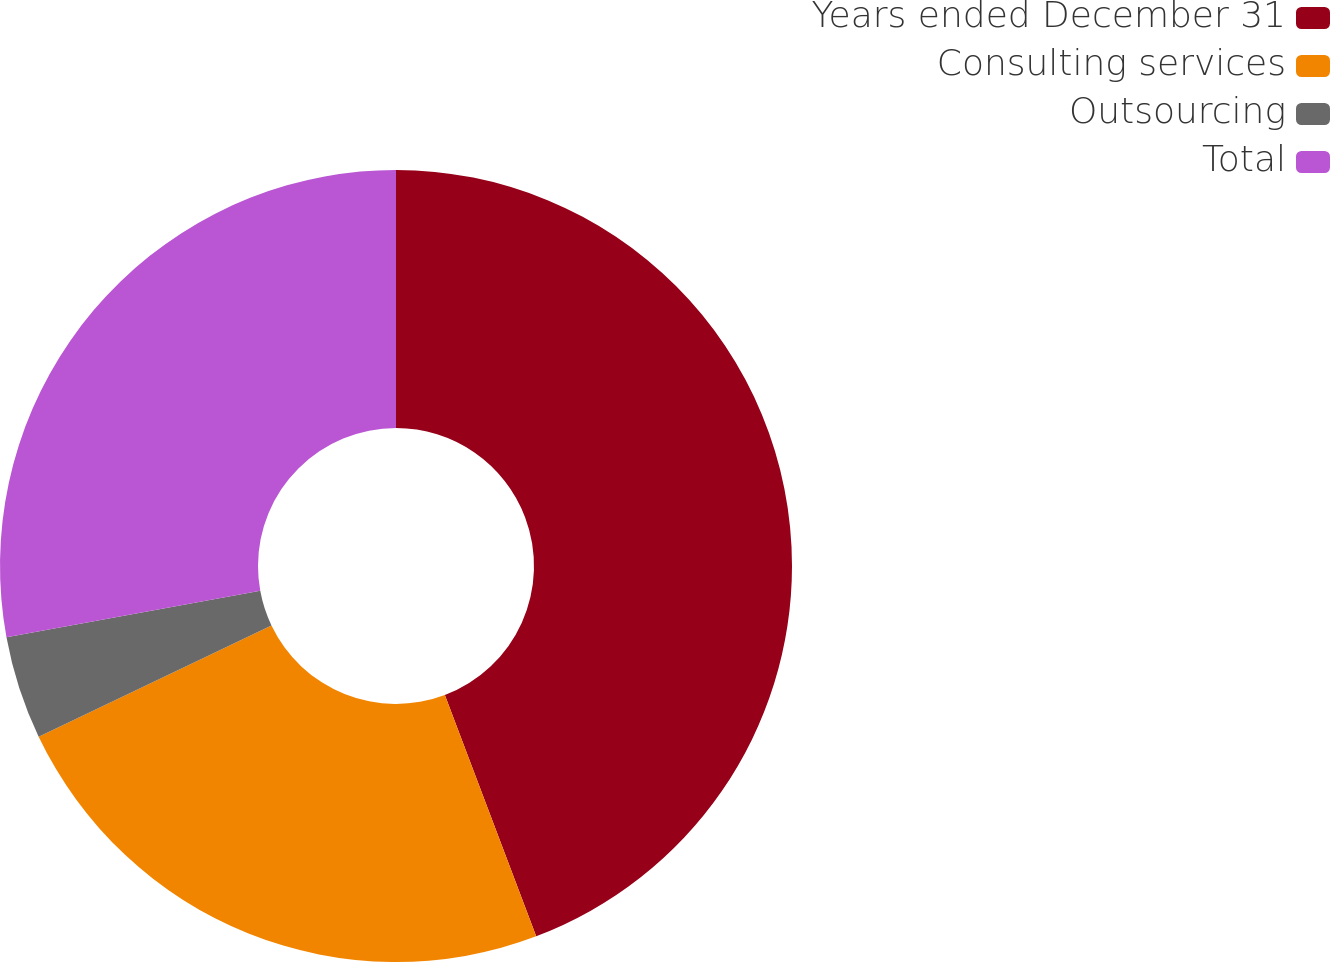Convert chart to OTSL. <chart><loc_0><loc_0><loc_500><loc_500><pie_chart><fcel>Years ended December 31<fcel>Consulting services<fcel>Outsourcing<fcel>Total<nl><fcel>44.24%<fcel>23.67%<fcel>4.21%<fcel>27.88%<nl></chart> 